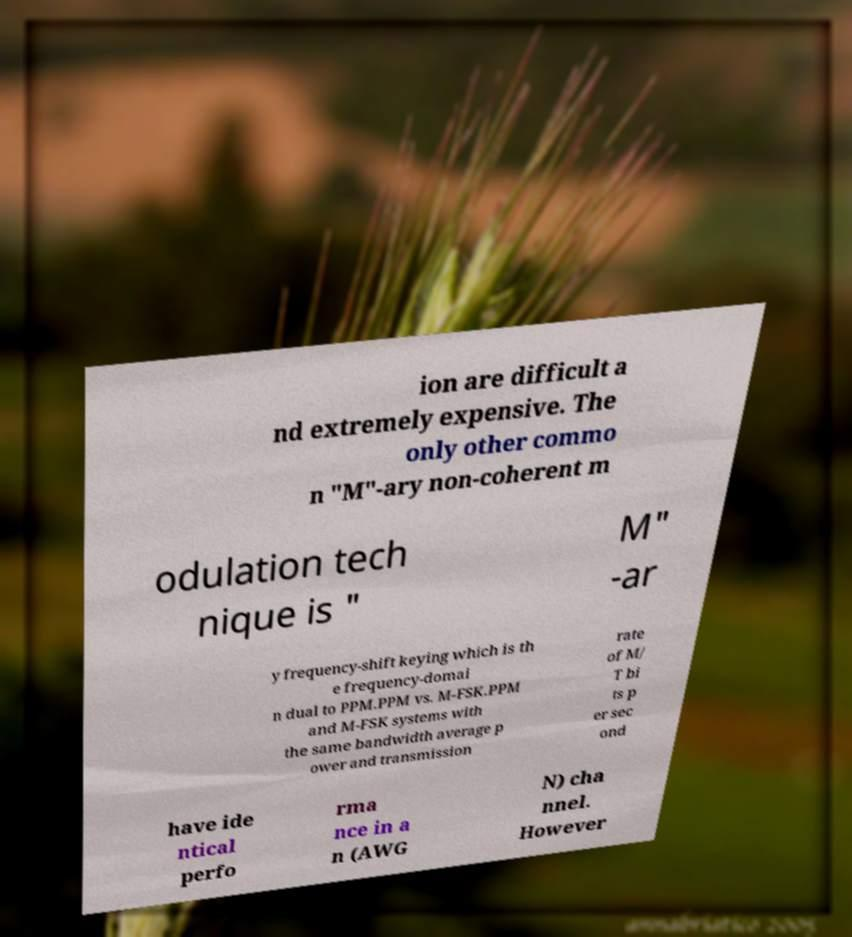Can you accurately transcribe the text from the provided image for me? ion are difficult a nd extremely expensive. The only other commo n "M"-ary non-coherent m odulation tech nique is " M" -ar y frequency-shift keying which is th e frequency-domai n dual to PPM.PPM vs. M-FSK.PPM and M-FSK systems with the same bandwidth average p ower and transmission rate of M/ T bi ts p er sec ond have ide ntical perfo rma nce in a n (AWG N) cha nnel. However 